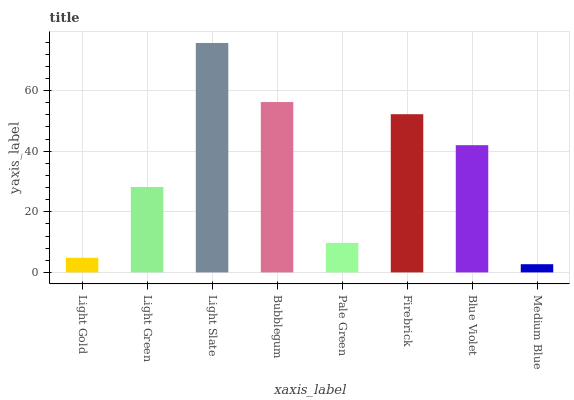Is Medium Blue the minimum?
Answer yes or no. Yes. Is Light Slate the maximum?
Answer yes or no. Yes. Is Light Green the minimum?
Answer yes or no. No. Is Light Green the maximum?
Answer yes or no. No. Is Light Green greater than Light Gold?
Answer yes or no. Yes. Is Light Gold less than Light Green?
Answer yes or no. Yes. Is Light Gold greater than Light Green?
Answer yes or no. No. Is Light Green less than Light Gold?
Answer yes or no. No. Is Blue Violet the high median?
Answer yes or no. Yes. Is Light Green the low median?
Answer yes or no. Yes. Is Bubblegum the high median?
Answer yes or no. No. Is Pale Green the low median?
Answer yes or no. No. 